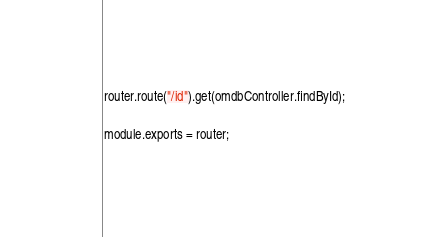<code> <loc_0><loc_0><loc_500><loc_500><_JavaScript_>router.route("/id").get(omdbController.findById);

module.exports = router;
</code> 